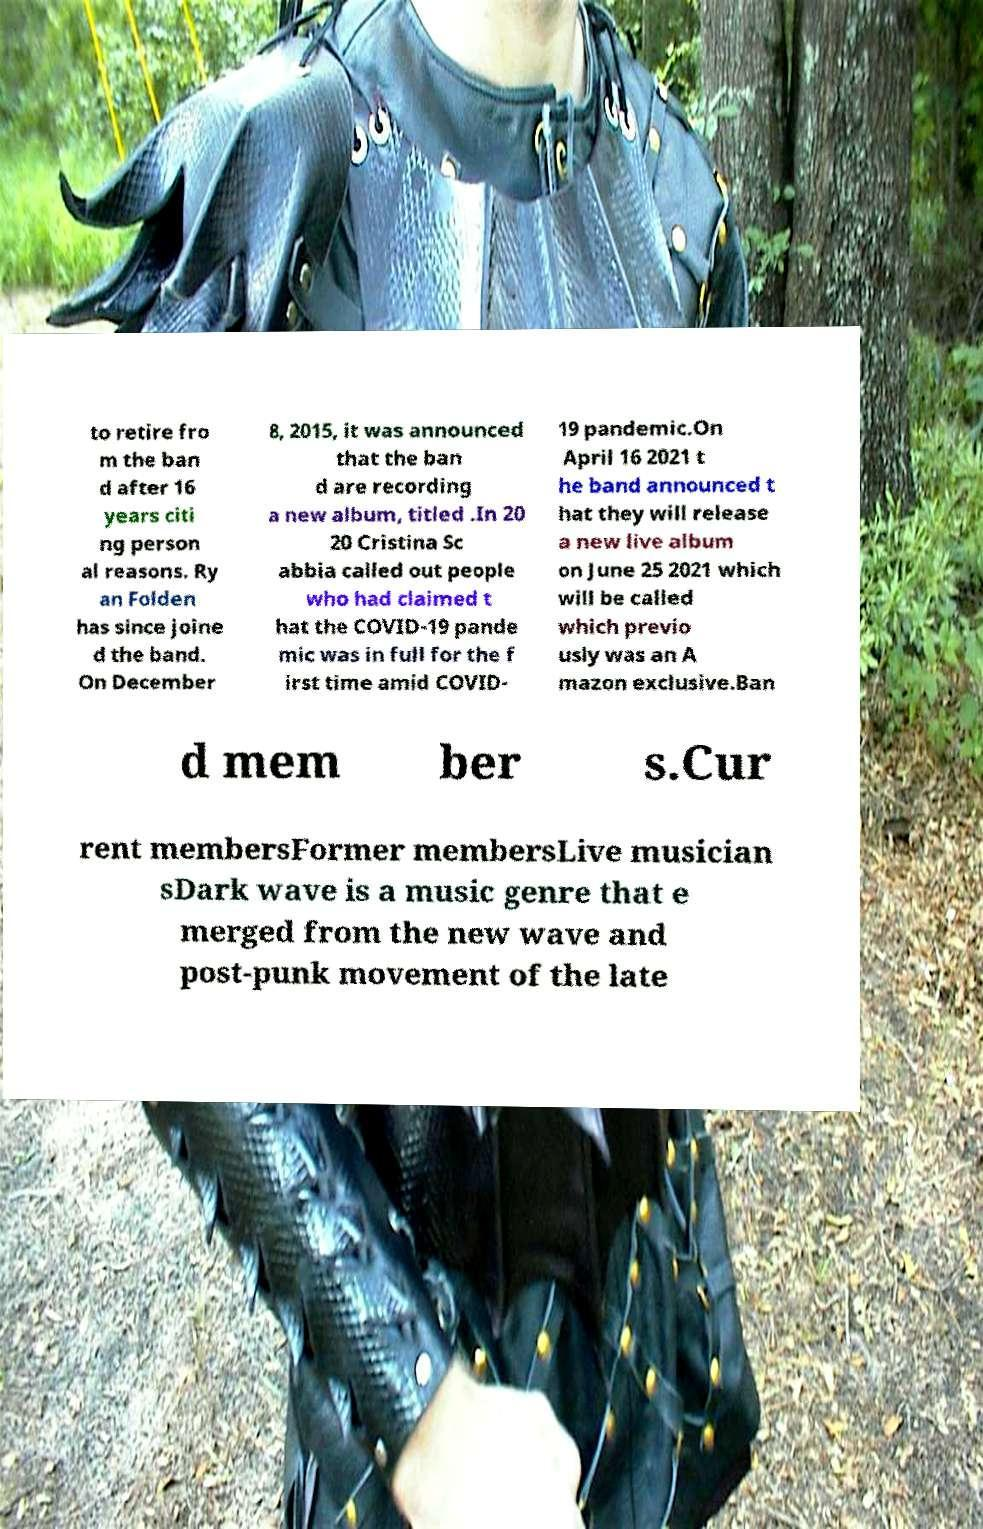There's text embedded in this image that I need extracted. Can you transcribe it verbatim? to retire fro m the ban d after 16 years citi ng person al reasons. Ry an Folden has since joine d the band. On December 8, 2015, it was announced that the ban d are recording a new album, titled .In 20 20 Cristina Sc abbia called out people who had claimed t hat the COVID-19 pande mic was in full for the f irst time amid COVID- 19 pandemic.On April 16 2021 t he band announced t hat they will release a new live album on June 25 2021 which will be called which previo usly was an A mazon exclusive.Ban d mem ber s.Cur rent membersFormer membersLive musician sDark wave is a music genre that e merged from the new wave and post-punk movement of the late 